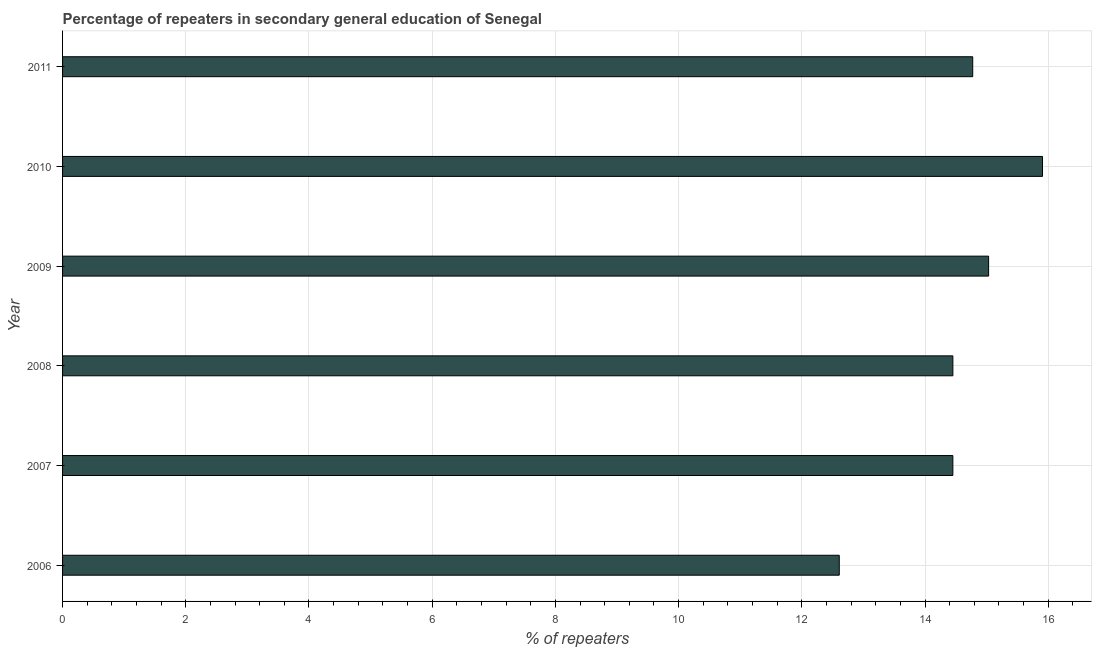Does the graph contain grids?
Your answer should be compact. Yes. What is the title of the graph?
Provide a short and direct response. Percentage of repeaters in secondary general education of Senegal. What is the label or title of the X-axis?
Ensure brevity in your answer.  % of repeaters. What is the percentage of repeaters in 2006?
Your answer should be very brief. 12.61. Across all years, what is the maximum percentage of repeaters?
Your answer should be compact. 15.91. Across all years, what is the minimum percentage of repeaters?
Make the answer very short. 12.61. What is the sum of the percentage of repeaters?
Offer a very short reply. 87.23. What is the difference between the percentage of repeaters in 2008 and 2009?
Keep it short and to the point. -0.58. What is the average percentage of repeaters per year?
Keep it short and to the point. 14.54. What is the median percentage of repeaters?
Your answer should be compact. 14.61. Is the percentage of repeaters in 2009 less than that in 2011?
Your answer should be compact. No. Is the difference between the percentage of repeaters in 2008 and 2010 greater than the difference between any two years?
Provide a short and direct response. No. Is the sum of the percentage of repeaters in 2008 and 2011 greater than the maximum percentage of repeaters across all years?
Your answer should be very brief. Yes. What is the difference between the highest and the lowest percentage of repeaters?
Provide a short and direct response. 3.3. In how many years, is the percentage of repeaters greater than the average percentage of repeaters taken over all years?
Provide a short and direct response. 3. What is the % of repeaters in 2006?
Your answer should be very brief. 12.61. What is the % of repeaters of 2007?
Provide a short and direct response. 14.45. What is the % of repeaters in 2008?
Offer a terse response. 14.45. What is the % of repeaters in 2009?
Ensure brevity in your answer.  15.03. What is the % of repeaters of 2010?
Offer a very short reply. 15.91. What is the % of repeaters in 2011?
Provide a succinct answer. 14.77. What is the difference between the % of repeaters in 2006 and 2007?
Your answer should be very brief. -1.84. What is the difference between the % of repeaters in 2006 and 2008?
Offer a very short reply. -1.84. What is the difference between the % of repeaters in 2006 and 2009?
Your answer should be very brief. -2.42. What is the difference between the % of repeaters in 2006 and 2010?
Give a very brief answer. -3.3. What is the difference between the % of repeaters in 2006 and 2011?
Provide a short and direct response. -2.17. What is the difference between the % of repeaters in 2007 and 2008?
Ensure brevity in your answer.  -6e-5. What is the difference between the % of repeaters in 2007 and 2009?
Keep it short and to the point. -0.58. What is the difference between the % of repeaters in 2007 and 2010?
Your answer should be compact. -1.45. What is the difference between the % of repeaters in 2007 and 2011?
Keep it short and to the point. -0.32. What is the difference between the % of repeaters in 2008 and 2009?
Provide a succinct answer. -0.58. What is the difference between the % of repeaters in 2008 and 2010?
Provide a succinct answer. -1.45. What is the difference between the % of repeaters in 2008 and 2011?
Keep it short and to the point. -0.32. What is the difference between the % of repeaters in 2009 and 2010?
Provide a succinct answer. -0.87. What is the difference between the % of repeaters in 2009 and 2011?
Keep it short and to the point. 0.26. What is the difference between the % of repeaters in 2010 and 2011?
Offer a very short reply. 1.13. What is the ratio of the % of repeaters in 2006 to that in 2007?
Your answer should be compact. 0.87. What is the ratio of the % of repeaters in 2006 to that in 2008?
Provide a short and direct response. 0.87. What is the ratio of the % of repeaters in 2006 to that in 2009?
Your answer should be very brief. 0.84. What is the ratio of the % of repeaters in 2006 to that in 2010?
Your answer should be very brief. 0.79. What is the ratio of the % of repeaters in 2006 to that in 2011?
Offer a very short reply. 0.85. What is the ratio of the % of repeaters in 2007 to that in 2010?
Offer a very short reply. 0.91. What is the ratio of the % of repeaters in 2007 to that in 2011?
Your response must be concise. 0.98. What is the ratio of the % of repeaters in 2008 to that in 2010?
Offer a terse response. 0.91. What is the ratio of the % of repeaters in 2008 to that in 2011?
Offer a terse response. 0.98. What is the ratio of the % of repeaters in 2009 to that in 2010?
Your response must be concise. 0.94. What is the ratio of the % of repeaters in 2009 to that in 2011?
Your answer should be very brief. 1.02. What is the ratio of the % of repeaters in 2010 to that in 2011?
Give a very brief answer. 1.08. 